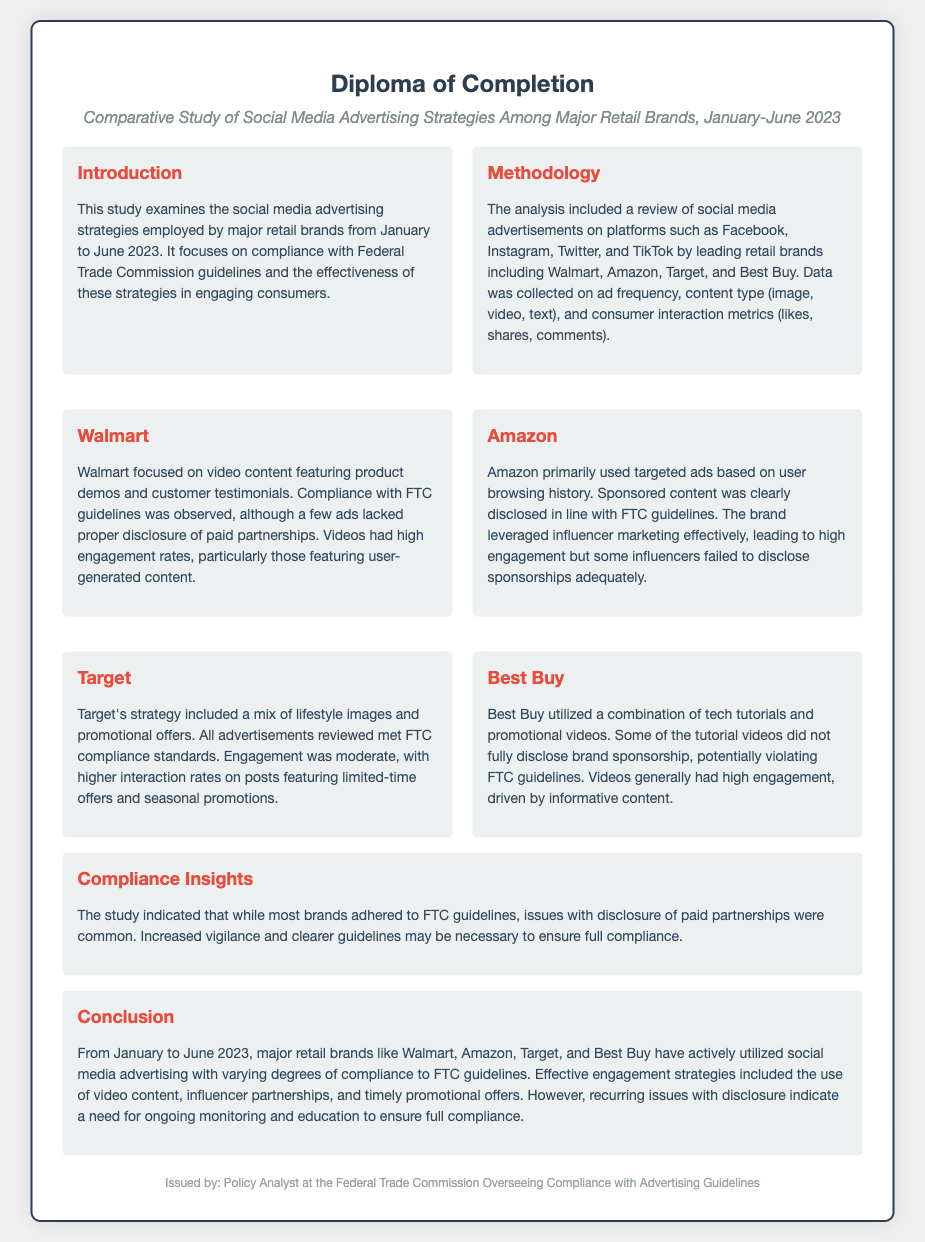What is the title of the study? The title of the study as mentioned in the document is clearly stated at the top.
Answer: Comparative Study of Social Media Advertising Strategies Among Major Retail Brands, January-June 2023 Which retail brands were examined in the study? The document lists the retail brands analyzed in the methodology section.
Answer: Walmart, Amazon, Target, Best Buy What type of content did Walmart primarily use? The section on Walmart describes the main content type they focused on in their advertisements.
Answer: Video content What was the engagement trend for Target's limited-time offers? The document specifies how Target's engagement differed for certain types of advertisements.
Answer: Higher interaction rates What compliance issues were noted for Best Buy? The analysis of Best Buy's strategy highlights a specific compliance oversight regarding their ads.
Answer: Disclosure of brand sponsorship How many retail brands were analyzed in this study? The number of brands is referenced in the methodology section when discussing the brands included.
Answer: Four What type of advertisements did Amazon utilize for targeting users? Amazon's advertisement approach is mentioned, focusing on how they targeted their users.
Answer: Targeted ads What insight regarding FTC compliance was provided in the study conclusion? The conclusion summarizes overall compliance issues noted across the studied brands.
Answer: Issues with disclosure 